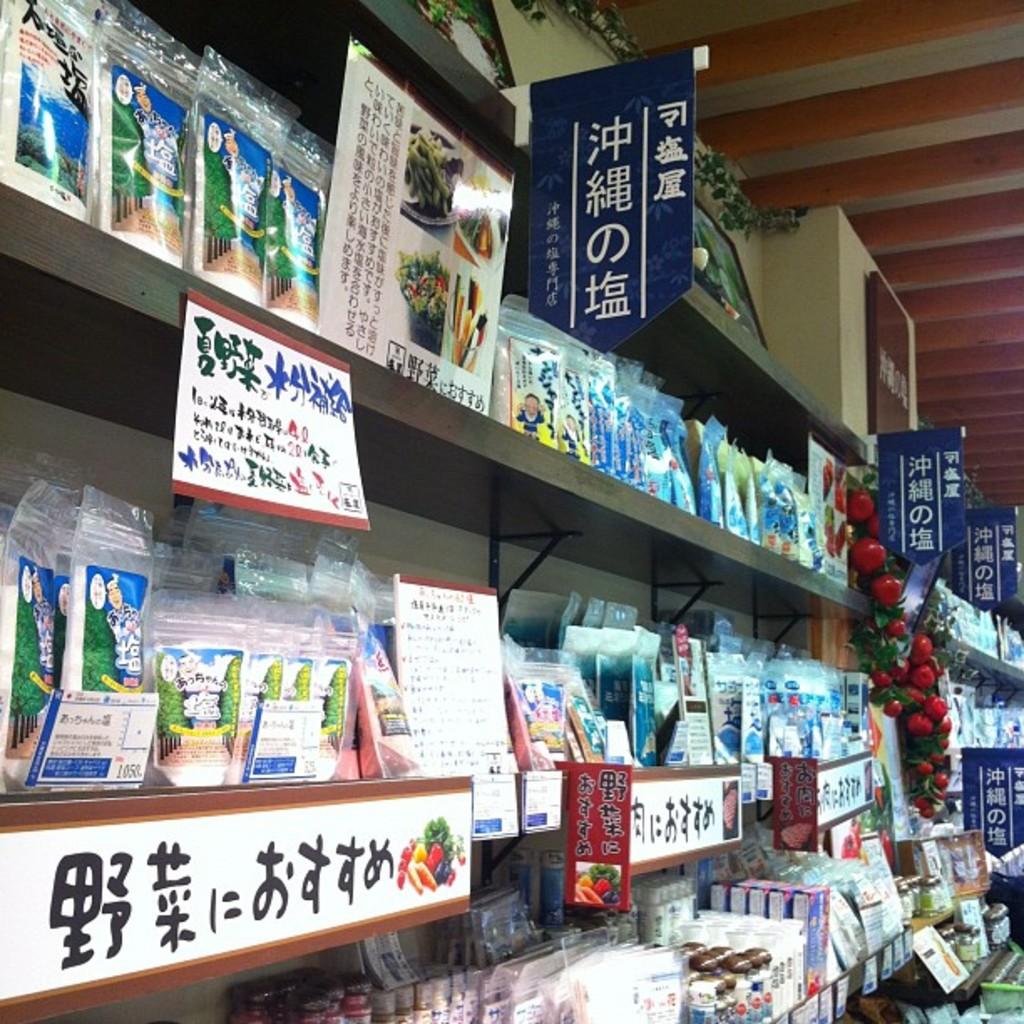Is this a chinese market?
Provide a short and direct response. Yes. 